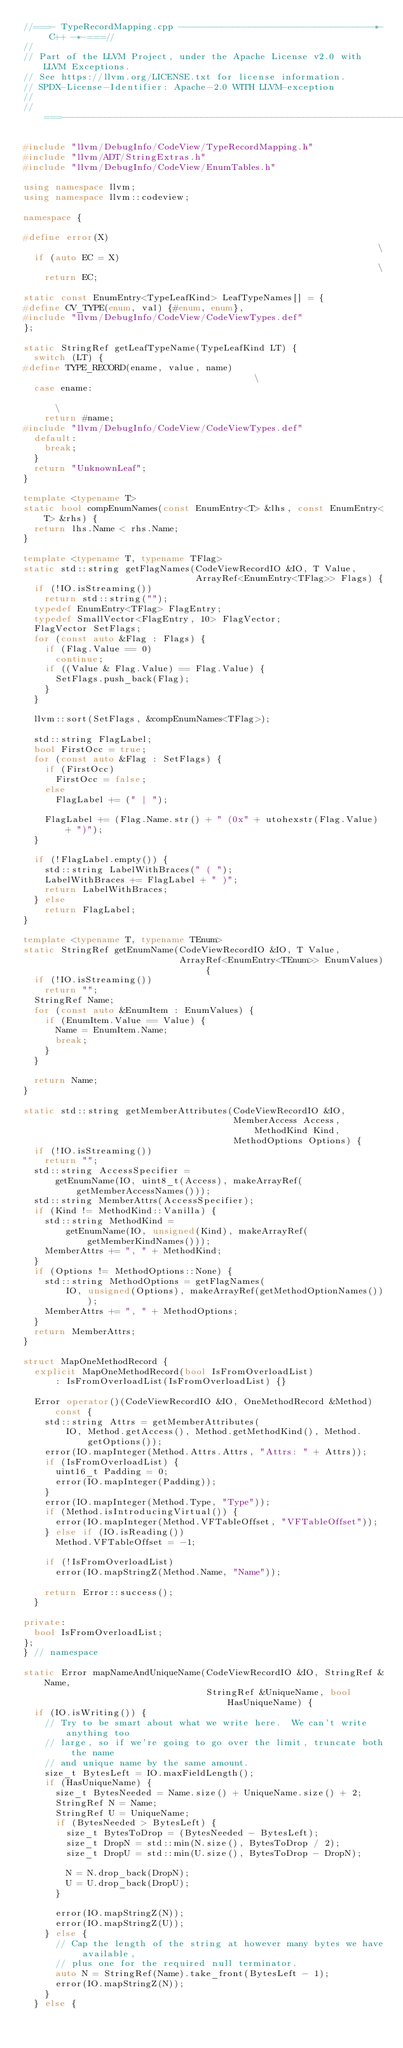Convert code to text. <code><loc_0><loc_0><loc_500><loc_500><_C++_>//===- TypeRecordMapping.cpp ------------------------------------*- C++ -*-===//
//
// Part of the LLVM Project, under the Apache License v2.0 with LLVM Exceptions.
// See https://llvm.org/LICENSE.txt for license information.
// SPDX-License-Identifier: Apache-2.0 WITH LLVM-exception
//
//===----------------------------------------------------------------------===//

#include "llvm/DebugInfo/CodeView/TypeRecordMapping.h"
#include "llvm/ADT/StringExtras.h"
#include "llvm/DebugInfo/CodeView/EnumTables.h"

using namespace llvm;
using namespace llvm::codeview;

namespace {

#define error(X)                                                               \
  if (auto EC = X)                                                             \
    return EC;

static const EnumEntry<TypeLeafKind> LeafTypeNames[] = {
#define CV_TYPE(enum, val) {#enum, enum},
#include "llvm/DebugInfo/CodeView/CodeViewTypes.def"
};

static StringRef getLeafTypeName(TypeLeafKind LT) {
  switch (LT) {
#define TYPE_RECORD(ename, value, name)                                        \
  case ename:                                                                  \
    return #name;
#include "llvm/DebugInfo/CodeView/CodeViewTypes.def"
  default:
    break;
  }
  return "UnknownLeaf";
}

template <typename T>
static bool compEnumNames(const EnumEntry<T> &lhs, const EnumEntry<T> &rhs) {
  return lhs.Name < rhs.Name;
}

template <typename T, typename TFlag>
static std::string getFlagNames(CodeViewRecordIO &IO, T Value,
                                ArrayRef<EnumEntry<TFlag>> Flags) {
  if (!IO.isStreaming())
    return std::string("");
  typedef EnumEntry<TFlag> FlagEntry;
  typedef SmallVector<FlagEntry, 10> FlagVector;
  FlagVector SetFlags;
  for (const auto &Flag : Flags) {
    if (Flag.Value == 0)
      continue;
    if ((Value & Flag.Value) == Flag.Value) {
      SetFlags.push_back(Flag);
    }
  }

  llvm::sort(SetFlags, &compEnumNames<TFlag>);

  std::string FlagLabel;
  bool FirstOcc = true;
  for (const auto &Flag : SetFlags) {
    if (FirstOcc)
      FirstOcc = false;
    else
      FlagLabel += (" | ");

    FlagLabel += (Flag.Name.str() + " (0x" + utohexstr(Flag.Value) + ")");
  }

  if (!FlagLabel.empty()) {
    std::string LabelWithBraces(" ( ");
    LabelWithBraces += FlagLabel + " )";
    return LabelWithBraces;
  } else
    return FlagLabel;
}

template <typename T, typename TEnum>
static StringRef getEnumName(CodeViewRecordIO &IO, T Value,
                             ArrayRef<EnumEntry<TEnum>> EnumValues) {
  if (!IO.isStreaming())
    return "";
  StringRef Name;
  for (const auto &EnumItem : EnumValues) {
    if (EnumItem.Value == Value) {
      Name = EnumItem.Name;
      break;
    }
  }

  return Name;
}

static std::string getMemberAttributes(CodeViewRecordIO &IO,
                                       MemberAccess Access, MethodKind Kind,
                                       MethodOptions Options) {
  if (!IO.isStreaming())
    return "";
  std::string AccessSpecifier =
      getEnumName(IO, uint8_t(Access), makeArrayRef(getMemberAccessNames()));
  std::string MemberAttrs(AccessSpecifier);
  if (Kind != MethodKind::Vanilla) {
    std::string MethodKind =
        getEnumName(IO, unsigned(Kind), makeArrayRef(getMemberKindNames()));
    MemberAttrs += ", " + MethodKind;
  }
  if (Options != MethodOptions::None) {
    std::string MethodOptions = getFlagNames(
        IO, unsigned(Options), makeArrayRef(getMethodOptionNames()));
    MemberAttrs += ", " + MethodOptions;
  }
  return MemberAttrs;
}

struct MapOneMethodRecord {
  explicit MapOneMethodRecord(bool IsFromOverloadList)
      : IsFromOverloadList(IsFromOverloadList) {}

  Error operator()(CodeViewRecordIO &IO, OneMethodRecord &Method) const {
    std::string Attrs = getMemberAttributes(
        IO, Method.getAccess(), Method.getMethodKind(), Method.getOptions());
    error(IO.mapInteger(Method.Attrs.Attrs, "Attrs: " + Attrs));
    if (IsFromOverloadList) {
      uint16_t Padding = 0;
      error(IO.mapInteger(Padding));
    }
    error(IO.mapInteger(Method.Type, "Type"));
    if (Method.isIntroducingVirtual()) {
      error(IO.mapInteger(Method.VFTableOffset, "VFTableOffset"));
    } else if (IO.isReading())
      Method.VFTableOffset = -1;

    if (!IsFromOverloadList)
      error(IO.mapStringZ(Method.Name, "Name"));

    return Error::success();
  }

private:
  bool IsFromOverloadList;
};
} // namespace

static Error mapNameAndUniqueName(CodeViewRecordIO &IO, StringRef &Name,
                                  StringRef &UniqueName, bool HasUniqueName) {
  if (IO.isWriting()) {
    // Try to be smart about what we write here.  We can't write anything too
    // large, so if we're going to go over the limit, truncate both the name
    // and unique name by the same amount.
    size_t BytesLeft = IO.maxFieldLength();
    if (HasUniqueName) {
      size_t BytesNeeded = Name.size() + UniqueName.size() + 2;
      StringRef N = Name;
      StringRef U = UniqueName;
      if (BytesNeeded > BytesLeft) {
        size_t BytesToDrop = (BytesNeeded - BytesLeft);
        size_t DropN = std::min(N.size(), BytesToDrop / 2);
        size_t DropU = std::min(U.size(), BytesToDrop - DropN);

        N = N.drop_back(DropN);
        U = U.drop_back(DropU);
      }

      error(IO.mapStringZ(N));
      error(IO.mapStringZ(U));
    } else {
      // Cap the length of the string at however many bytes we have available,
      // plus one for the required null terminator.
      auto N = StringRef(Name).take_front(BytesLeft - 1);
      error(IO.mapStringZ(N));
    }
  } else {</code> 